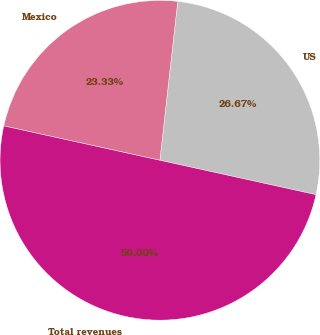Convert chart to OTSL. <chart><loc_0><loc_0><loc_500><loc_500><pie_chart><fcel>US<fcel>Mexico<fcel>Total revenues<nl><fcel>26.67%<fcel>23.33%<fcel>50.0%<nl></chart> 